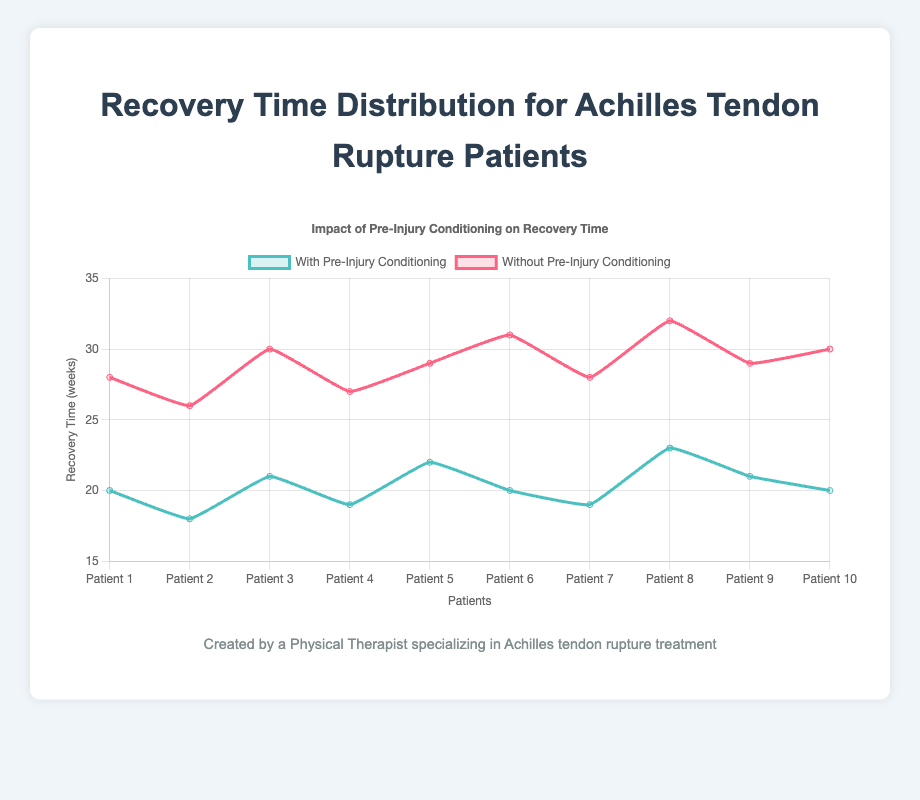Which group shows a shorter recovery time on average? To determine the group with the shorter average recovery time, we calculate the average for both groups. Sum of recovery times for the pre-injury conditioning group is (20 + 18 + 21 + 19 + 22 + 20 + 19 + 23 + 21 + 20) = 203, and the average is 203/10 = 20.3 weeks. Sum of recovery times for the group without conditioning is (28 + 26 + 30 + 27 + 29 + 31 + 28 + 32 + 29 + 30) = 290, and the average is 290/10 = 29 weeks. Therefore, the pre-injury conditioning group has a shorter average recovery time.
Answer: Pre-injury conditioning group What is the median recovery time for the group without pre-injury conditioning? To find the median, we first order the data for the group without pre-injury conditioning: 26, 27, 28, 28, 29, 29, 30, 30, 31, 32. The median is the average of the fifth and sixth values: (29 + 29)/2 = 29 weeks.
Answer: 29 weeks How much longer, on average, is the recovery time without pre-injury conditioning compared to with pre-injury conditioning? Calculate the average recovery time for each group as in the first question: without pre-injury conditioning is 29 weeks, and with pre-injury conditioning is 20.3 weeks. The difference is 29 - 20.3 = 8.7 weeks.
Answer: 8.7 weeks Which dataset has a wider range of recovery times? The range is the difference between the maximum and minimum values. For the pre-injury conditioning group, range is 23 - 18 = 5 weeks. For the group without conditioning, range is 32 - 26 = 6 weeks. Therefore, the group without conditioning has a wider range.
Answer: Without conditioning group Does any patient in the pre-injury conditioning group recover faster than all patients in the group without conditioning? The fastest recovery time in the pre-injury conditioning group is 18 weeks. The fastest recovery time in the group without conditioning is 26 weeks. Since 18 weeks is less than 26 weeks, yes, at least one patient in the pre-injury conditioning group recovers faster than all patients in the group without conditioning.
Answer: Yes Which recovery time is more frequently observed in the pre-injury conditioning group? By examining the data for the pre-injury conditioning group: 20 is observed 3 times (P01, P06, P10), while other values appear less frequently. Therefore, 20 weeks is the most frequent recovery time in this group.
Answer: 20 weeks Is there any patient in the without pre-injury conditioning group with a recovery time of less than 25 weeks? By looking at the dataset for the group without pre-injury conditioning, all recovery times are 26 weeks or more. Thus, there are no recovery times less than 25 weeks.
Answer: No 